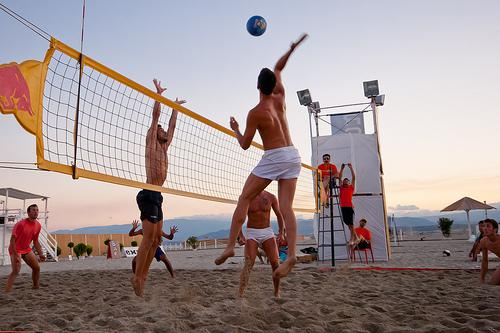Question: what sport is this?
Choices:
A. Basketball.
B. Football.
C. Baseball.
D. Volleyball.
Answer with the letter. Answer: D Question: who is there?
Choices:
A. Beachgoers.
B. Men.
C. Women.
D. Children.
Answer with the letter. Answer: A Question: what is being hit?
Choices:
A. The ball.
B. The car.
C. The home.
D. The person.
Answer with the letter. Answer: A Question: what are they standing on?
Choices:
A. Mud.
B. Water.
C. Sand.
D. Concrete.
Answer with the letter. Answer: C Question: how is the sky?
Choices:
A. Clear.
B. Overcast.
C. Cloudy.
D. Densely cloudy.
Answer with the letter. Answer: A Question: where is this scene?
Choices:
A. The home.
B. The car.
C. The church.
D. The beach.
Answer with the letter. Answer: D Question: why are they jumping?
Choices:
A. For the gold.
B. For the sky.
C. For the ball.
D. To beat gravity.
Answer with the letter. Answer: C Question: when is this?
Choices:
A. Early morning.
B. Early evening.
C. Afternoon.
D. Midnight.
Answer with the letter. Answer: B 